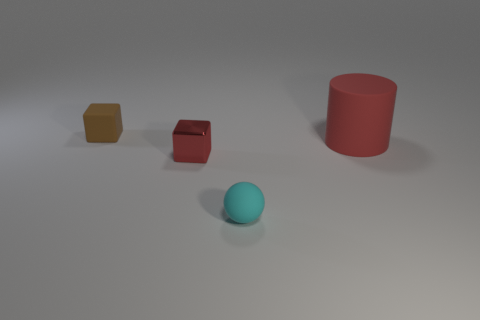Subtract all brown cubes. How many cubes are left? 1 Add 4 tiny gray matte blocks. How many objects exist? 8 Subtract all cylinders. How many objects are left? 3 Subtract all gray blocks. How many green cylinders are left? 0 Subtract all red blocks. Subtract all large red things. How many objects are left? 2 Add 4 tiny things. How many tiny things are left? 7 Add 1 cyan spheres. How many cyan spheres exist? 2 Subtract 0 yellow cylinders. How many objects are left? 4 Subtract 2 blocks. How many blocks are left? 0 Subtract all red cubes. Subtract all yellow balls. How many cubes are left? 1 